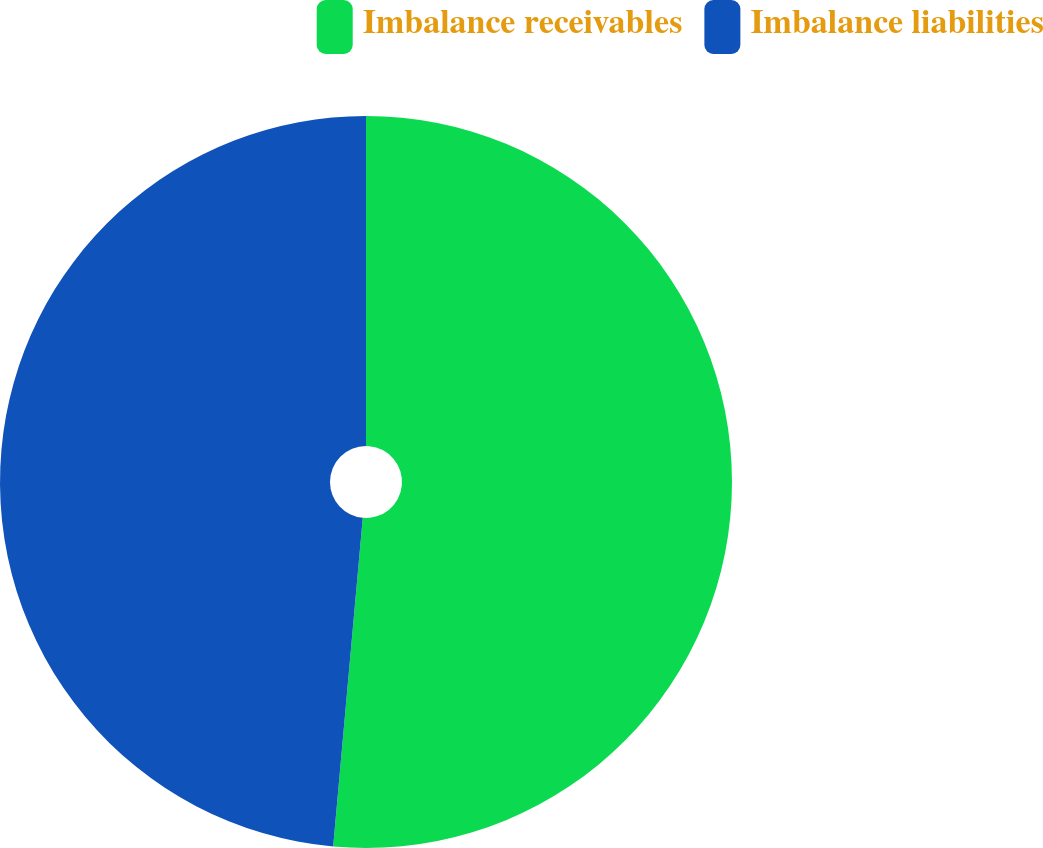<chart> <loc_0><loc_0><loc_500><loc_500><pie_chart><fcel>Imbalance receivables<fcel>Imbalance liabilities<nl><fcel>51.43%<fcel>48.57%<nl></chart> 